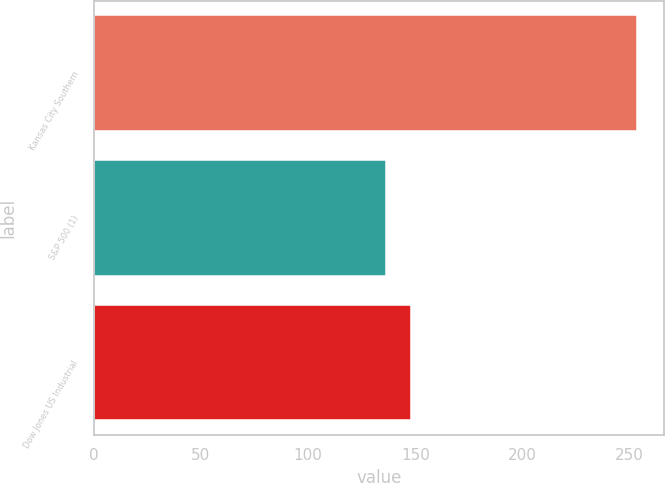Convert chart to OTSL. <chart><loc_0><loc_0><loc_500><loc_500><bar_chart><fcel>Kansas City Southern<fcel>S&P 500 (1)<fcel>Dow Jones US Industrial<nl><fcel>253.42<fcel>136.3<fcel>148.01<nl></chart> 